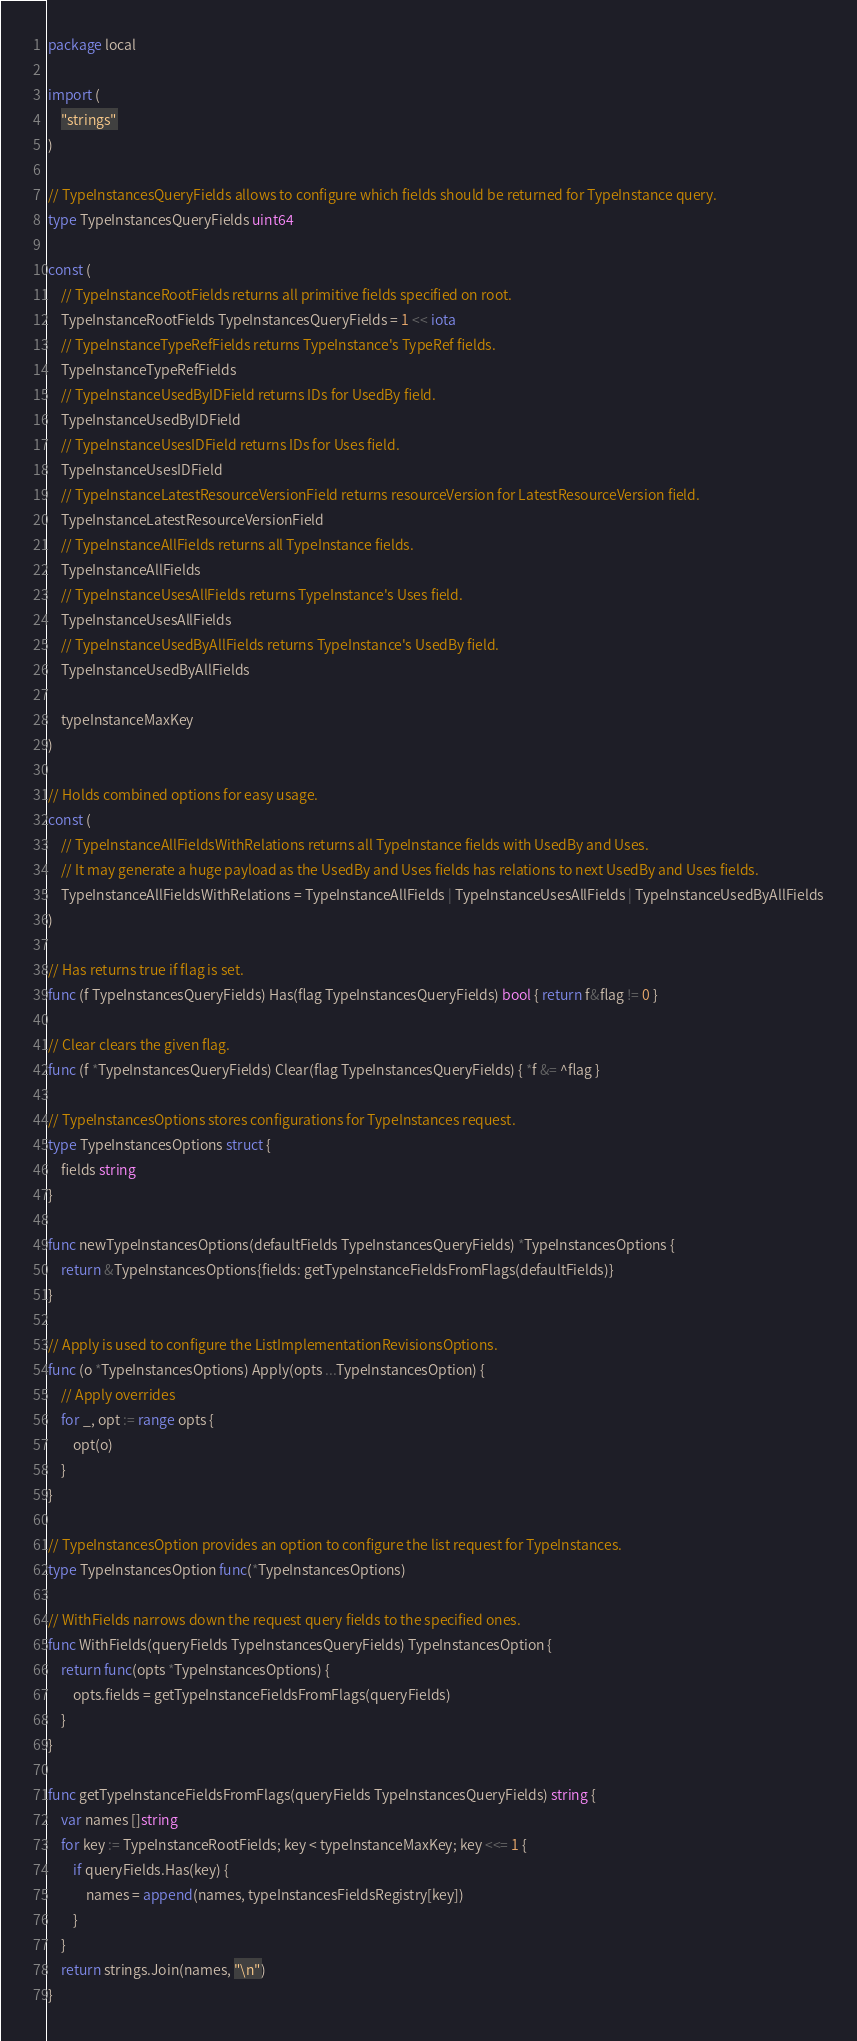Convert code to text. <code><loc_0><loc_0><loc_500><loc_500><_Go_>package local

import (
	"strings"
)

// TypeInstancesQueryFields allows to configure which fields should be returned for TypeInstance query.
type TypeInstancesQueryFields uint64

const (
	// TypeInstanceRootFields returns all primitive fields specified on root.
	TypeInstanceRootFields TypeInstancesQueryFields = 1 << iota
	// TypeInstanceTypeRefFields returns TypeInstance's TypeRef fields.
	TypeInstanceTypeRefFields
	// TypeInstanceUsedByIDField returns IDs for UsedBy field.
	TypeInstanceUsedByIDField
	// TypeInstanceUsesIDField returns IDs for Uses field.
	TypeInstanceUsesIDField
	// TypeInstanceLatestResourceVersionField returns resourceVersion for LatestResourceVersion field.
	TypeInstanceLatestResourceVersionField
	// TypeInstanceAllFields returns all TypeInstance fields.
	TypeInstanceAllFields
	// TypeInstanceUsesAllFields returns TypeInstance's Uses field.
	TypeInstanceUsesAllFields
	// TypeInstanceUsedByAllFields returns TypeInstance's UsedBy field.
	TypeInstanceUsedByAllFields

	typeInstanceMaxKey
)

// Holds combined options for easy usage.
const (
	// TypeInstanceAllFieldsWithRelations returns all TypeInstance fields with UsedBy and Uses.
	// It may generate a huge payload as the UsedBy and Uses fields has relations to next UsedBy and Uses fields.
	TypeInstanceAllFieldsWithRelations = TypeInstanceAllFields | TypeInstanceUsesAllFields | TypeInstanceUsedByAllFields
)

// Has returns true if flag is set.
func (f TypeInstancesQueryFields) Has(flag TypeInstancesQueryFields) bool { return f&flag != 0 }

// Clear clears the given flag.
func (f *TypeInstancesQueryFields) Clear(flag TypeInstancesQueryFields) { *f &= ^flag }

// TypeInstancesOptions stores configurations for TypeInstances request.
type TypeInstancesOptions struct {
	fields string
}

func newTypeInstancesOptions(defaultFields TypeInstancesQueryFields) *TypeInstancesOptions {
	return &TypeInstancesOptions{fields: getTypeInstanceFieldsFromFlags(defaultFields)}
}

// Apply is used to configure the ListImplementationRevisionsOptions.
func (o *TypeInstancesOptions) Apply(opts ...TypeInstancesOption) {
	// Apply overrides
	for _, opt := range opts {
		opt(o)
	}
}

// TypeInstancesOption provides an option to configure the list request for TypeInstances.
type TypeInstancesOption func(*TypeInstancesOptions)

// WithFields narrows down the request query fields to the specified ones.
func WithFields(queryFields TypeInstancesQueryFields) TypeInstancesOption {
	return func(opts *TypeInstancesOptions) {
		opts.fields = getTypeInstanceFieldsFromFlags(queryFields)
	}
}

func getTypeInstanceFieldsFromFlags(queryFields TypeInstancesQueryFields) string {
	var names []string
	for key := TypeInstanceRootFields; key < typeInstanceMaxKey; key <<= 1 {
		if queryFields.Has(key) {
			names = append(names, typeInstancesFieldsRegistry[key])
		}
	}
	return strings.Join(names, "\n")
}
</code> 